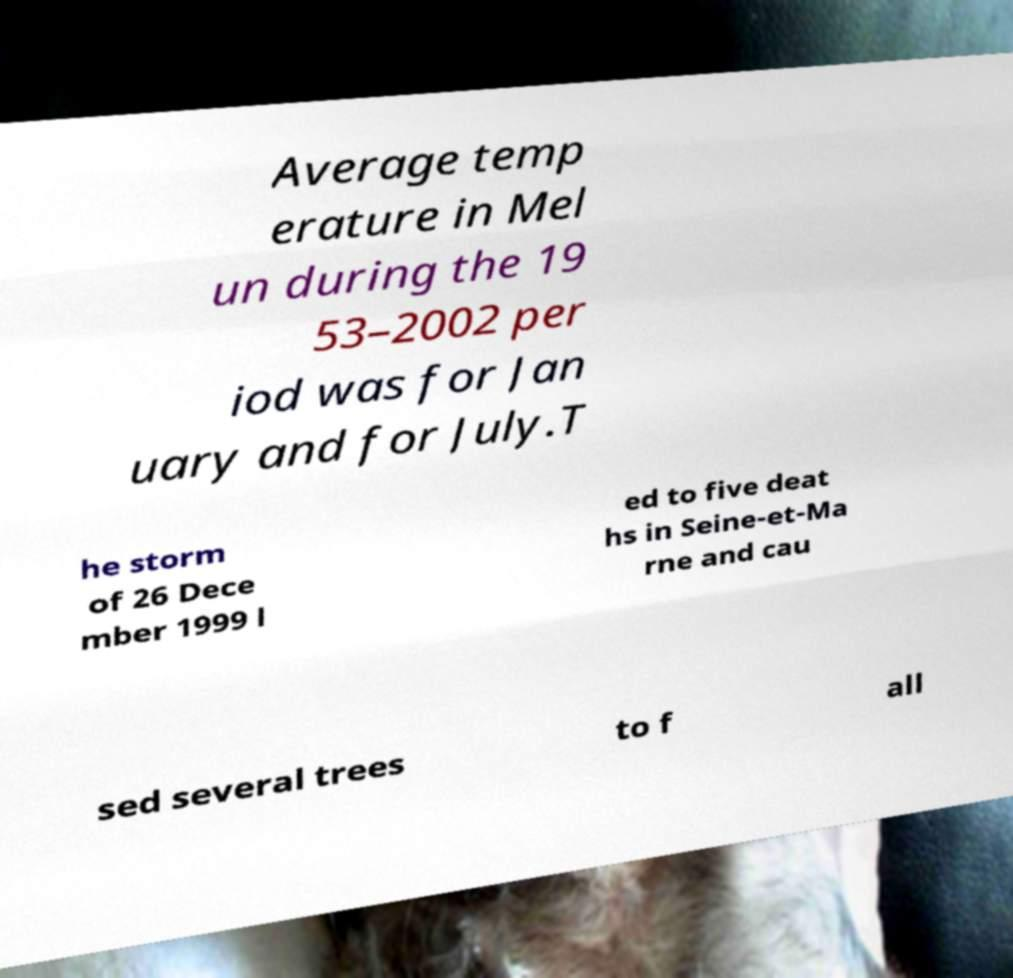Please identify and transcribe the text found in this image. Average temp erature in Mel un during the 19 53–2002 per iod was for Jan uary and for July.T he storm of 26 Dece mber 1999 l ed to five deat hs in Seine-et-Ma rne and cau sed several trees to f all 